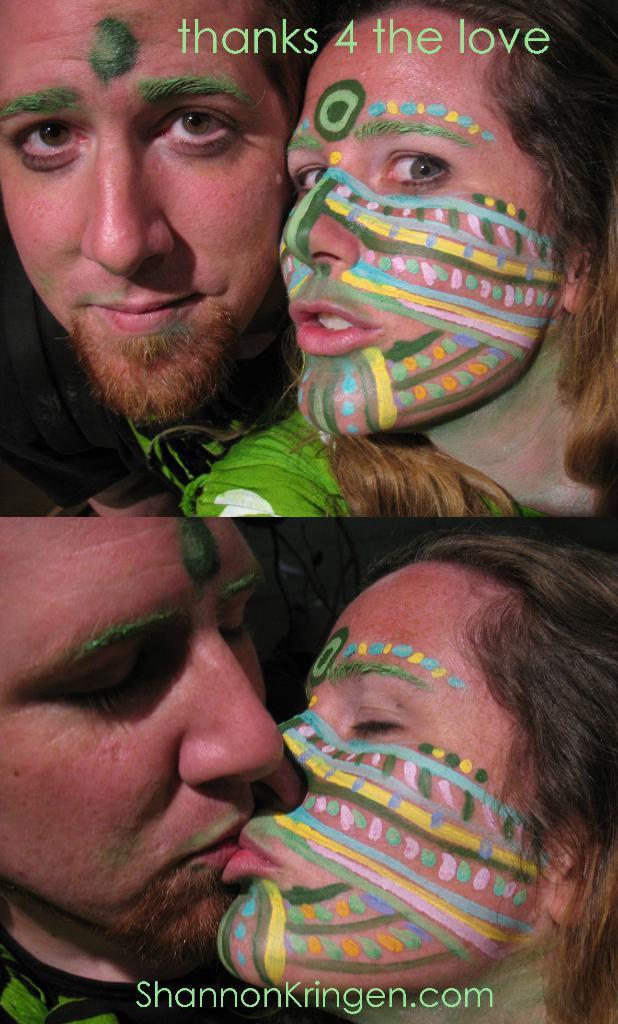Describe this image in one or two sentences. This image is a collage image as we can see there are two person on the top of this image and there is some text written at top of this image and there are two persons on the bottom of this image and they are kissing ,and there is some text written at bottom of this image. 